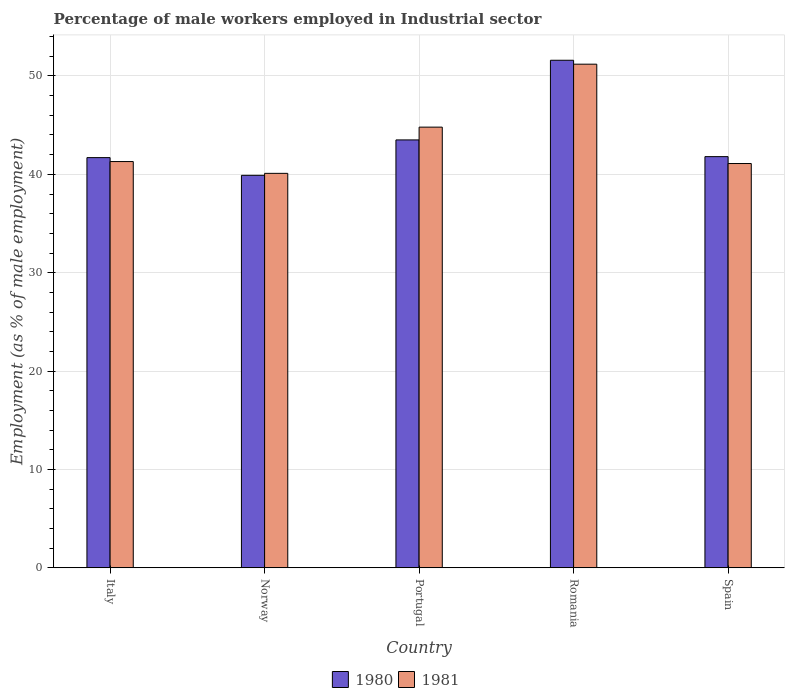How many different coloured bars are there?
Your answer should be compact. 2. Are the number of bars per tick equal to the number of legend labels?
Keep it short and to the point. Yes. How many bars are there on the 2nd tick from the right?
Provide a succinct answer. 2. What is the label of the 4th group of bars from the left?
Ensure brevity in your answer.  Romania. What is the percentage of male workers employed in Industrial sector in 1981 in Romania?
Provide a succinct answer. 51.2. Across all countries, what is the maximum percentage of male workers employed in Industrial sector in 1980?
Your answer should be very brief. 51.6. Across all countries, what is the minimum percentage of male workers employed in Industrial sector in 1981?
Keep it short and to the point. 40.1. In which country was the percentage of male workers employed in Industrial sector in 1981 maximum?
Make the answer very short. Romania. What is the total percentage of male workers employed in Industrial sector in 1981 in the graph?
Provide a succinct answer. 218.5. What is the difference between the percentage of male workers employed in Industrial sector in 1981 in Portugal and that in Romania?
Your answer should be compact. -6.4. What is the difference between the percentage of male workers employed in Industrial sector in 1981 in Norway and the percentage of male workers employed in Industrial sector in 1980 in Spain?
Keep it short and to the point. -1.7. What is the average percentage of male workers employed in Industrial sector in 1980 per country?
Provide a succinct answer. 43.7. What is the difference between the percentage of male workers employed in Industrial sector of/in 1981 and percentage of male workers employed in Industrial sector of/in 1980 in Norway?
Keep it short and to the point. 0.2. In how many countries, is the percentage of male workers employed in Industrial sector in 1980 greater than 22 %?
Provide a short and direct response. 5. What is the ratio of the percentage of male workers employed in Industrial sector in 1981 in Romania to that in Spain?
Give a very brief answer. 1.25. Is the difference between the percentage of male workers employed in Industrial sector in 1981 in Norway and Portugal greater than the difference between the percentage of male workers employed in Industrial sector in 1980 in Norway and Portugal?
Provide a succinct answer. No. What is the difference between the highest and the second highest percentage of male workers employed in Industrial sector in 1980?
Your answer should be very brief. -8.1. What is the difference between the highest and the lowest percentage of male workers employed in Industrial sector in 1980?
Your answer should be very brief. 11.7. In how many countries, is the percentage of male workers employed in Industrial sector in 1981 greater than the average percentage of male workers employed in Industrial sector in 1981 taken over all countries?
Your response must be concise. 2. What does the 1st bar from the left in Norway represents?
Offer a very short reply. 1980. Are the values on the major ticks of Y-axis written in scientific E-notation?
Offer a very short reply. No. Does the graph contain grids?
Offer a very short reply. Yes. Where does the legend appear in the graph?
Make the answer very short. Bottom center. How many legend labels are there?
Offer a very short reply. 2. How are the legend labels stacked?
Offer a very short reply. Horizontal. What is the title of the graph?
Ensure brevity in your answer.  Percentage of male workers employed in Industrial sector. Does "1987" appear as one of the legend labels in the graph?
Your response must be concise. No. What is the label or title of the Y-axis?
Provide a short and direct response. Employment (as % of male employment). What is the Employment (as % of male employment) in 1980 in Italy?
Your answer should be compact. 41.7. What is the Employment (as % of male employment) in 1981 in Italy?
Provide a succinct answer. 41.3. What is the Employment (as % of male employment) of 1980 in Norway?
Ensure brevity in your answer.  39.9. What is the Employment (as % of male employment) in 1981 in Norway?
Ensure brevity in your answer.  40.1. What is the Employment (as % of male employment) of 1980 in Portugal?
Offer a terse response. 43.5. What is the Employment (as % of male employment) in 1981 in Portugal?
Provide a short and direct response. 44.8. What is the Employment (as % of male employment) in 1980 in Romania?
Provide a succinct answer. 51.6. What is the Employment (as % of male employment) in 1981 in Romania?
Your answer should be very brief. 51.2. What is the Employment (as % of male employment) in 1980 in Spain?
Make the answer very short. 41.8. What is the Employment (as % of male employment) of 1981 in Spain?
Give a very brief answer. 41.1. Across all countries, what is the maximum Employment (as % of male employment) of 1980?
Offer a terse response. 51.6. Across all countries, what is the maximum Employment (as % of male employment) in 1981?
Make the answer very short. 51.2. Across all countries, what is the minimum Employment (as % of male employment) of 1980?
Your answer should be very brief. 39.9. Across all countries, what is the minimum Employment (as % of male employment) of 1981?
Offer a very short reply. 40.1. What is the total Employment (as % of male employment) in 1980 in the graph?
Offer a very short reply. 218.5. What is the total Employment (as % of male employment) of 1981 in the graph?
Provide a succinct answer. 218.5. What is the difference between the Employment (as % of male employment) in 1981 in Italy and that in Norway?
Provide a short and direct response. 1.2. What is the difference between the Employment (as % of male employment) in 1980 in Italy and that in Portugal?
Offer a terse response. -1.8. What is the difference between the Employment (as % of male employment) in 1981 in Italy and that in Portugal?
Keep it short and to the point. -3.5. What is the difference between the Employment (as % of male employment) in 1980 in Italy and that in Romania?
Your response must be concise. -9.9. What is the difference between the Employment (as % of male employment) in 1981 in Italy and that in Romania?
Provide a short and direct response. -9.9. What is the difference between the Employment (as % of male employment) in 1980 in Italy and that in Spain?
Give a very brief answer. -0.1. What is the difference between the Employment (as % of male employment) of 1981 in Italy and that in Spain?
Keep it short and to the point. 0.2. What is the difference between the Employment (as % of male employment) of 1980 in Norway and that in Portugal?
Offer a terse response. -3.6. What is the difference between the Employment (as % of male employment) in 1980 in Norway and that in Spain?
Make the answer very short. -1.9. What is the difference between the Employment (as % of male employment) in 1980 in Portugal and that in Romania?
Keep it short and to the point. -8.1. What is the difference between the Employment (as % of male employment) of 1981 in Romania and that in Spain?
Offer a terse response. 10.1. What is the difference between the Employment (as % of male employment) in 1980 in Italy and the Employment (as % of male employment) in 1981 in Romania?
Your answer should be compact. -9.5. What is the difference between the Employment (as % of male employment) in 1980 in Italy and the Employment (as % of male employment) in 1981 in Spain?
Provide a short and direct response. 0.6. What is the difference between the Employment (as % of male employment) of 1980 in Norway and the Employment (as % of male employment) of 1981 in Portugal?
Provide a short and direct response. -4.9. What is the difference between the Employment (as % of male employment) of 1980 in Norway and the Employment (as % of male employment) of 1981 in Romania?
Give a very brief answer. -11.3. What is the difference between the Employment (as % of male employment) of 1980 in Portugal and the Employment (as % of male employment) of 1981 in Spain?
Make the answer very short. 2.4. What is the average Employment (as % of male employment) of 1980 per country?
Make the answer very short. 43.7. What is the average Employment (as % of male employment) of 1981 per country?
Make the answer very short. 43.7. What is the difference between the Employment (as % of male employment) of 1980 and Employment (as % of male employment) of 1981 in Italy?
Your answer should be compact. 0.4. What is the difference between the Employment (as % of male employment) of 1980 and Employment (as % of male employment) of 1981 in Norway?
Provide a succinct answer. -0.2. What is the difference between the Employment (as % of male employment) in 1980 and Employment (as % of male employment) in 1981 in Portugal?
Your answer should be compact. -1.3. What is the difference between the Employment (as % of male employment) of 1980 and Employment (as % of male employment) of 1981 in Spain?
Keep it short and to the point. 0.7. What is the ratio of the Employment (as % of male employment) in 1980 in Italy to that in Norway?
Provide a short and direct response. 1.05. What is the ratio of the Employment (as % of male employment) of 1981 in Italy to that in Norway?
Offer a very short reply. 1.03. What is the ratio of the Employment (as % of male employment) in 1980 in Italy to that in Portugal?
Ensure brevity in your answer.  0.96. What is the ratio of the Employment (as % of male employment) of 1981 in Italy to that in Portugal?
Offer a terse response. 0.92. What is the ratio of the Employment (as % of male employment) of 1980 in Italy to that in Romania?
Your answer should be very brief. 0.81. What is the ratio of the Employment (as % of male employment) in 1981 in Italy to that in Romania?
Ensure brevity in your answer.  0.81. What is the ratio of the Employment (as % of male employment) in 1981 in Italy to that in Spain?
Offer a terse response. 1. What is the ratio of the Employment (as % of male employment) of 1980 in Norway to that in Portugal?
Keep it short and to the point. 0.92. What is the ratio of the Employment (as % of male employment) of 1981 in Norway to that in Portugal?
Your response must be concise. 0.9. What is the ratio of the Employment (as % of male employment) of 1980 in Norway to that in Romania?
Your response must be concise. 0.77. What is the ratio of the Employment (as % of male employment) of 1981 in Norway to that in Romania?
Make the answer very short. 0.78. What is the ratio of the Employment (as % of male employment) in 1980 in Norway to that in Spain?
Offer a terse response. 0.95. What is the ratio of the Employment (as % of male employment) in 1981 in Norway to that in Spain?
Your response must be concise. 0.98. What is the ratio of the Employment (as % of male employment) in 1980 in Portugal to that in Romania?
Give a very brief answer. 0.84. What is the ratio of the Employment (as % of male employment) in 1981 in Portugal to that in Romania?
Offer a terse response. 0.88. What is the ratio of the Employment (as % of male employment) of 1980 in Portugal to that in Spain?
Provide a succinct answer. 1.04. What is the ratio of the Employment (as % of male employment) of 1981 in Portugal to that in Spain?
Provide a short and direct response. 1.09. What is the ratio of the Employment (as % of male employment) of 1980 in Romania to that in Spain?
Offer a terse response. 1.23. What is the ratio of the Employment (as % of male employment) of 1981 in Romania to that in Spain?
Make the answer very short. 1.25. What is the difference between the highest and the second highest Employment (as % of male employment) of 1981?
Give a very brief answer. 6.4. What is the difference between the highest and the lowest Employment (as % of male employment) in 1981?
Give a very brief answer. 11.1. 